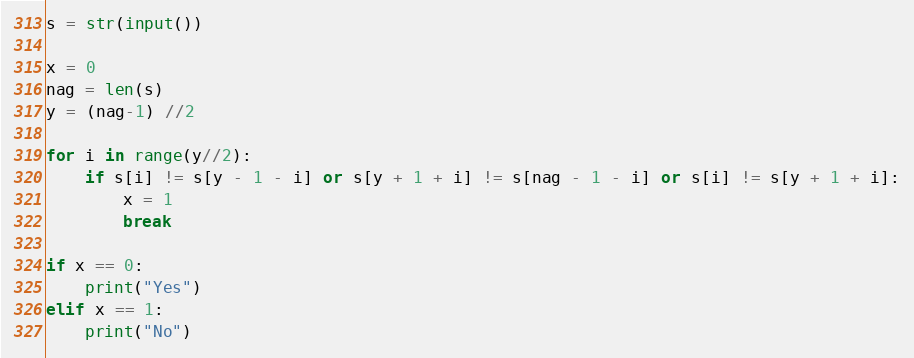<code> <loc_0><loc_0><loc_500><loc_500><_Python_>s = str(input())

x = 0
nag = len(s)
y = (nag-1) //2

for i in range(y//2):
    if s[i] != s[y - 1 - i] or s[y + 1 + i] != s[nag - 1 - i] or s[i] != s[y + 1 + i]:
        x = 1
        break

if x == 0:
    print("Yes")
elif x == 1:
    print("No")</code> 